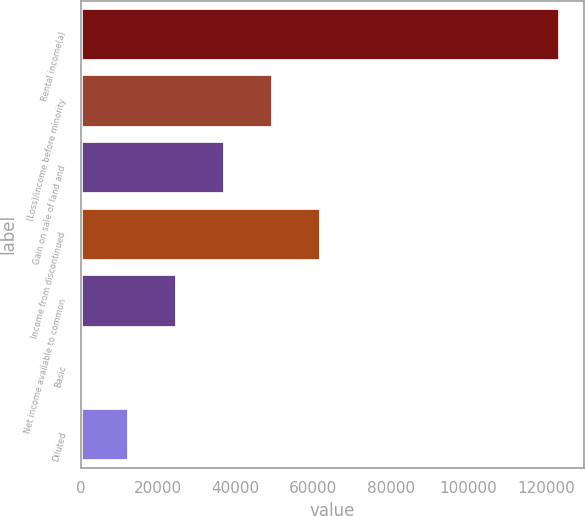Convert chart. <chart><loc_0><loc_0><loc_500><loc_500><bar_chart><fcel>Rental income(a)<fcel>(Loss)/income before minority<fcel>Gain on sale of land and<fcel>Income from discontinued<fcel>Net income available to common<fcel>Basic<fcel>Diluted<nl><fcel>123689<fcel>49475.6<fcel>37106.7<fcel>61844.5<fcel>24737.8<fcel>0.01<fcel>12368.9<nl></chart> 